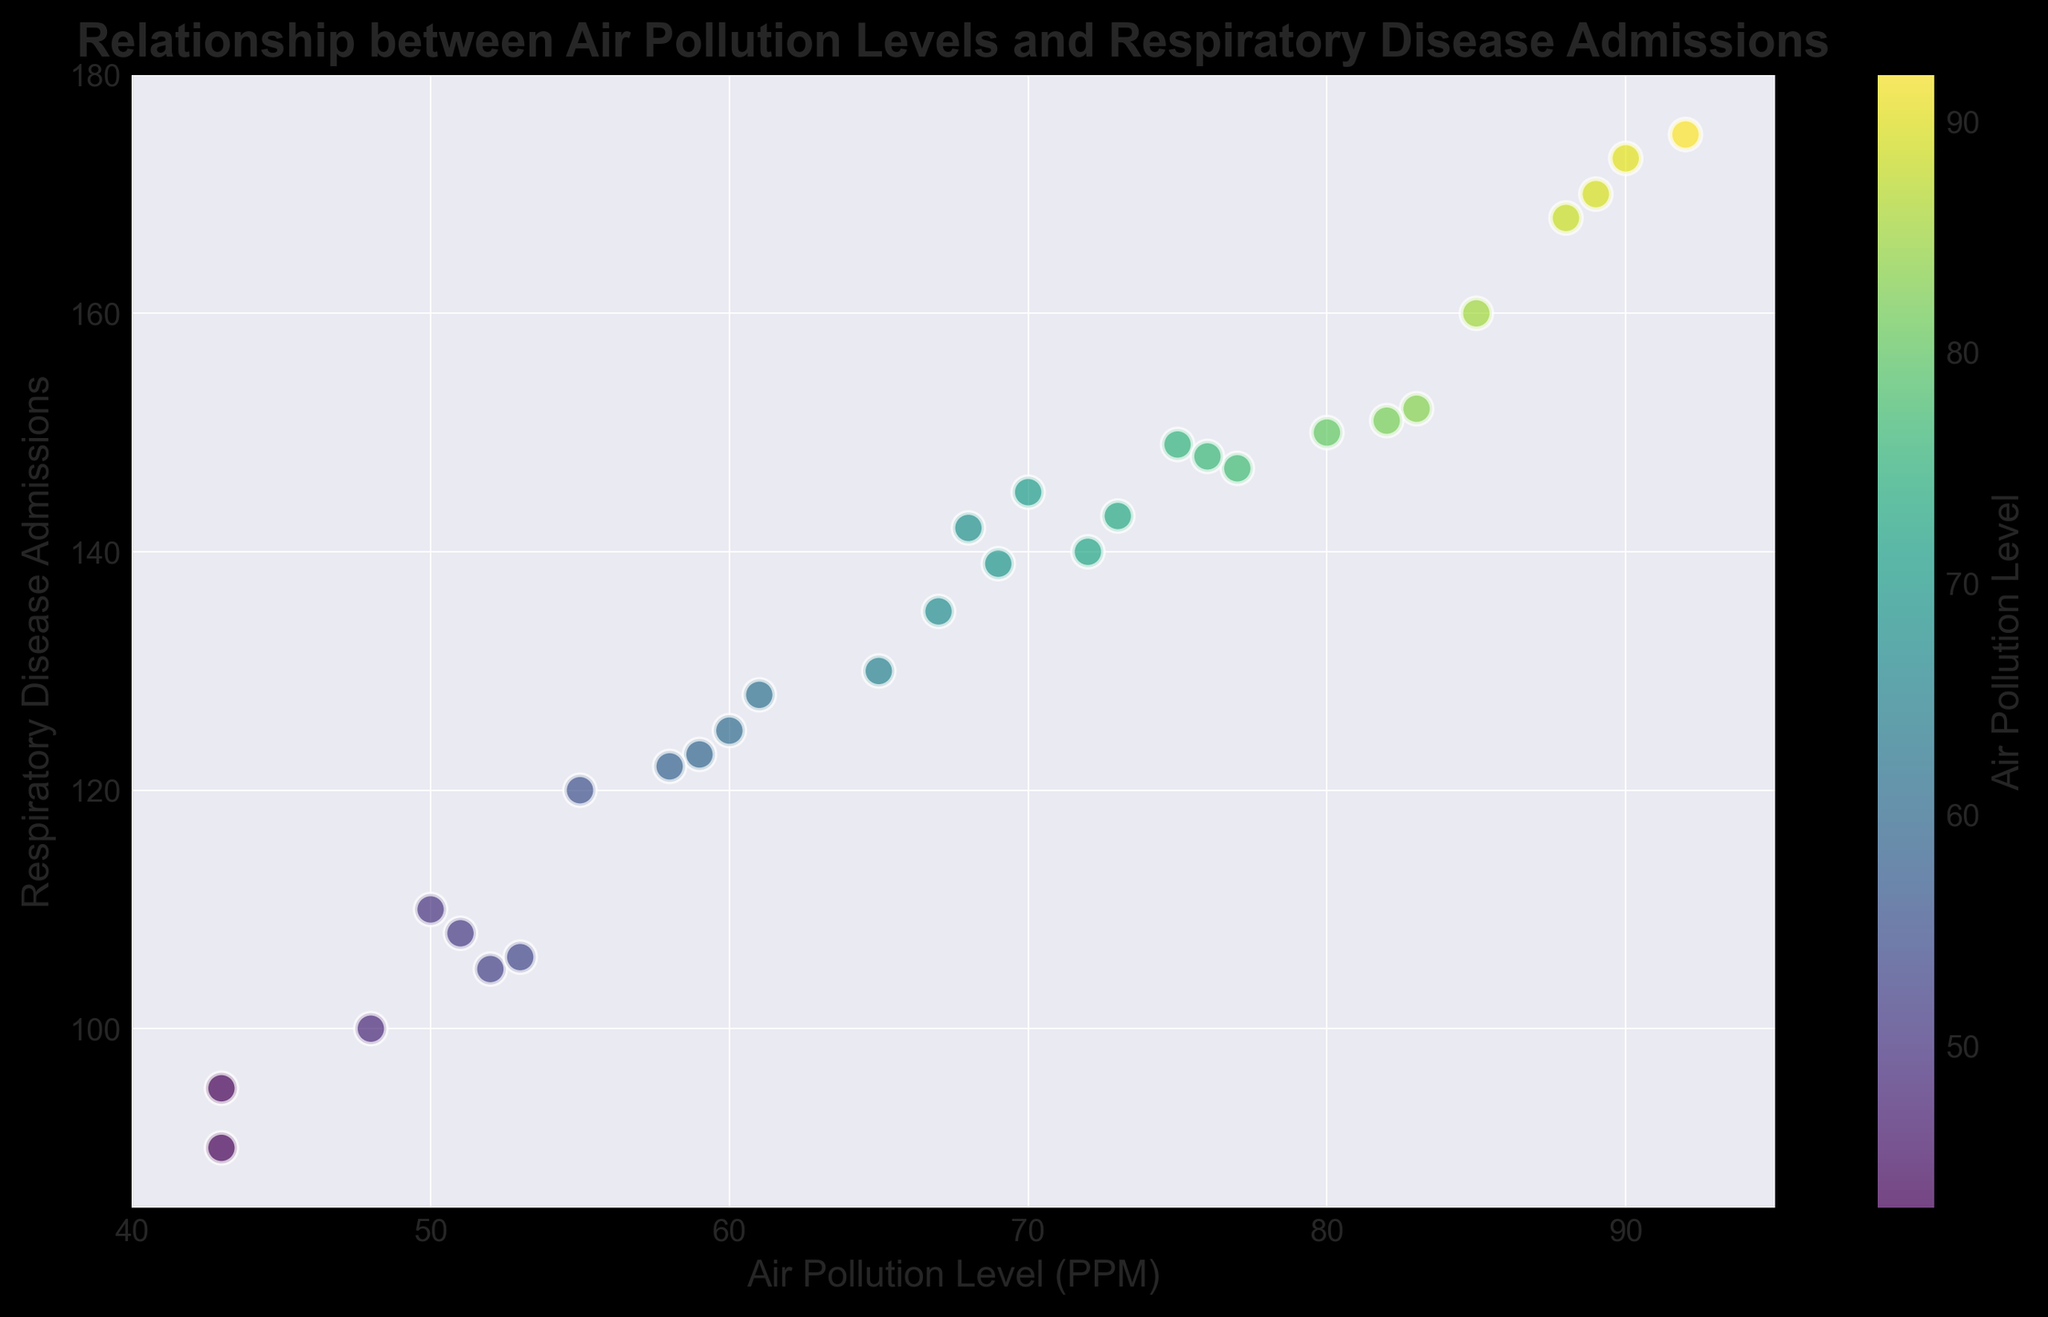Which day has the highest level of air pollution? The figure shows a scatter plot with air pollution levels on the x-axis. Look for the point with the maximum value on the x-axis, which corresponds to the highest air pollution level.
Answer: January 13 Are the air pollution levels and respiratory disease admissions positively correlated? Examine the general trend in the scatter plot. If the points cluster in an upward direction from left to right, there is a positive correlation.
Answer: Yes What is the range of air pollution levels displayed in the plot? Check the x-axis limits to find the minimum and maximum values of air pollution levels in the figure.
Answer: 40 to 95 On which day are respiratory disease admissions highest? The figure displays respiratory disease admissions on the y-axis. Identify the point with the highest y-value.
Answer: January 13 Which air pollution level corresponds to 120 respiratory disease admissions? Locate the point on the scatter plot with a y-value of 120 and find the corresponding x-value.
Answer: 55 Is there any day with a pollution level between 60 and 70 ppm and respiratory disease admissions between 120 and 140? Look for points within the x range of 60 to 70 and y range of 120 to 140 on the scatter plot.
Answer: January 6 (air pollution = 60, admissions = 125) What is the air pollution level on the day with the third-highest respiratory disease admissions? Identify days with the highest respiratory disease admissions firstly, then find the air pollution level for the third-highest point on the y-axis.
Answer: January 18 (air pollution = 89, admissions = 170) Describe the color variation representing air pollution level in the plot. Analyze the color gradient from the plot to see how the color changes with increasing air pollution levels. Usually, lighter or warmer colors indicate higher levels on a gradient scale.
Answer: Lighter greens to yellows represent higher pollution levels What is the air pollution level range for respiratory disease admissions between 140 and 150? Find points on the scatter plot within the y range of 140 to 150 and note the corresponding x values to determine the range.
Answer: 68 to 77 Which color corresponds to the lowest air pollution levels in the plot? Look at the color bar and assess the color at the lower end of the air pollution level range to see which color maps to the lowest values.
Answer: Dark green 